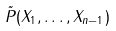Convert formula to latex. <formula><loc_0><loc_0><loc_500><loc_500>\tilde { P } ( X _ { 1 } , \dots , X _ { n - 1 } )</formula> 